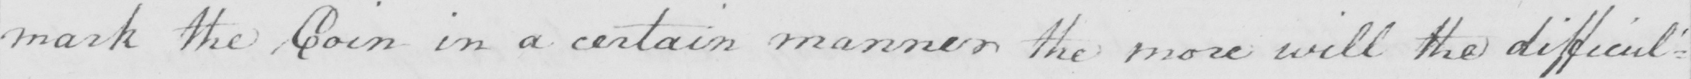Please provide the text content of this handwritten line. mark the Coin in a certain manner the more will the difficul : 